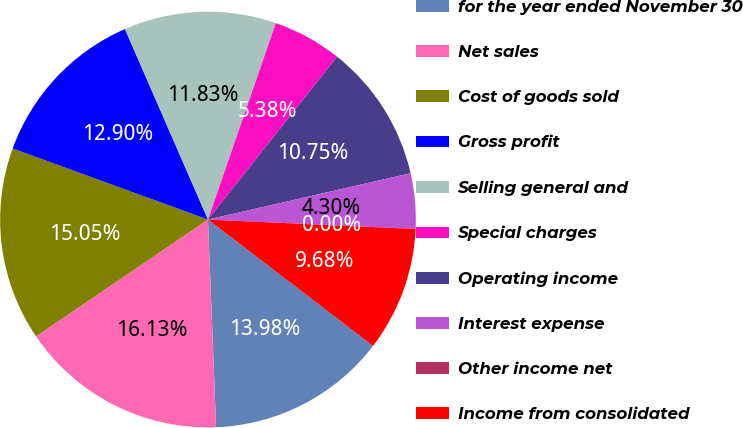Convert chart to OTSL. <chart><loc_0><loc_0><loc_500><loc_500><pie_chart><fcel>for the year ended November 30<fcel>Net sales<fcel>Cost of goods sold<fcel>Gross profit<fcel>Selling general and<fcel>Special charges<fcel>Operating income<fcel>Interest expense<fcel>Other income net<fcel>Income from consolidated<nl><fcel>13.98%<fcel>16.13%<fcel>15.05%<fcel>12.9%<fcel>11.83%<fcel>5.38%<fcel>10.75%<fcel>4.3%<fcel>0.0%<fcel>9.68%<nl></chart> 